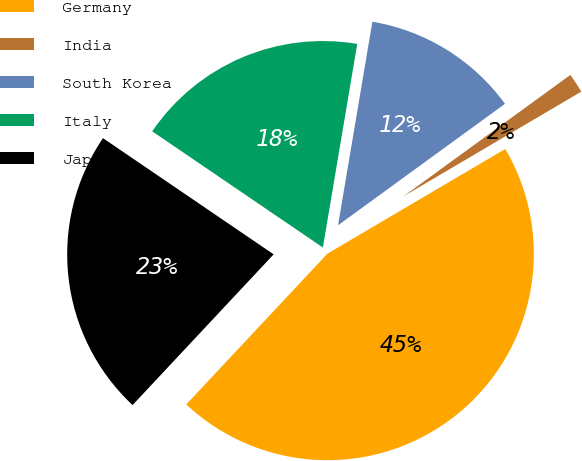<chart> <loc_0><loc_0><loc_500><loc_500><pie_chart><fcel>Germany<fcel>India<fcel>South Korea<fcel>Italy<fcel>Japan<nl><fcel>45.45%<fcel>1.54%<fcel>12.33%<fcel>18.15%<fcel>22.54%<nl></chart> 